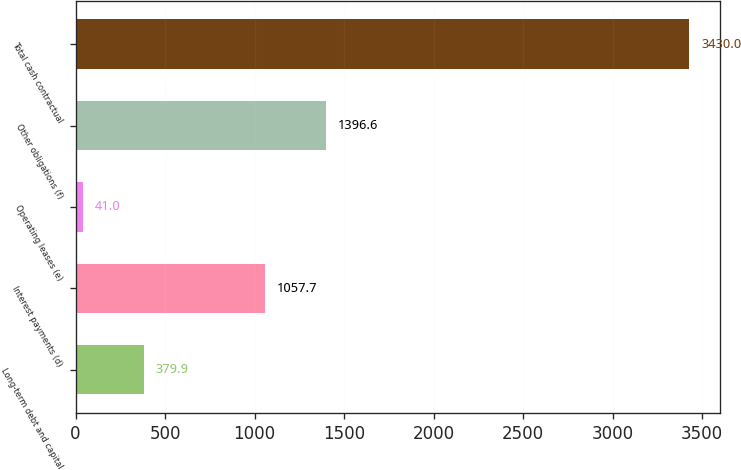Convert chart to OTSL. <chart><loc_0><loc_0><loc_500><loc_500><bar_chart><fcel>Long-term debt and capital<fcel>Interest payments (d)<fcel>Operating leases (e)<fcel>Other obligations (f)<fcel>Total cash contractual<nl><fcel>379.9<fcel>1057.7<fcel>41<fcel>1396.6<fcel>3430<nl></chart> 